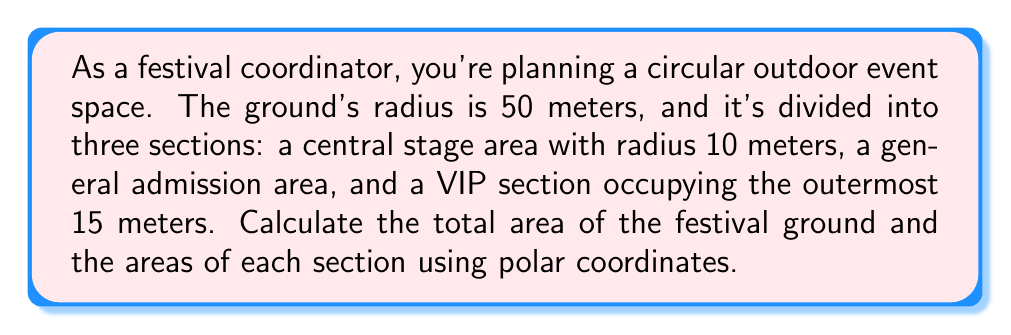Solve this math problem. To solve this problem, we'll use the formula for the area of a region in polar coordinates:

$$A = \frac{1}{2} \int_{0}^{2\pi} \int_{a}^{b} r^2 \, dr \, d\theta$$

Where $a$ and $b$ are the inner and outer radii of the region, respectively.

1. Total area of the festival ground:
   $$A_{total} = \frac{1}{2} \int_{0}^{2\pi} \int_{0}^{50} r^2 \, dr \, d\theta$$
   $$= \pi \int_{0}^{50} r^2 \, dr = \pi \left[ \frac{r^3}{3} \right]_{0}^{50}$$
   $$= \pi \cdot \frac{50^3}{3} = \frac{125000\pi}{3} \approx 130899.69 \, \text{m}^2$$

2. Central stage area:
   $$A_{stage} = \frac{1}{2} \int_{0}^{2\pi} \int_{0}^{10} r^2 \, dr \, d\theta$$
   $$= \pi \int_{0}^{10} r^2 \, dr = \pi \left[ \frac{r^3}{3} \right]_{0}^{10}$$
   $$= \pi \cdot \frac{10^3}{3} = \frac{1000\pi}{3} \approx 1047.20 \, \text{m}^2$$

3. VIP section area:
   $$A_{VIP} = \frac{1}{2} \int_{0}^{2\pi} \int_{35}^{50} r^2 \, dr \, d\theta$$
   $$= \pi \int_{35}^{50} r^2 \, dr = \pi \left[ \frac{r^3}{3} \right]_{35}^{50}$$
   $$= \pi \cdot \frac{50^3 - 35^3}{3} = \frac{91875\pi}{3} \approx 96130.44 \, \text{m}^2$$

4. General admission area:
   $$A_{general} = A_{total} - A_{stage} - A_{VIP}$$
   $$= \frac{125000\pi}{3} - \frac{1000\pi}{3} - \frac{91875\pi}{3}$$
   $$= \frac{32125\pi}{3} \approx 33722.05 \, \text{m}^2$$
Answer: Total festival ground area: $\frac{125000\pi}{3} \approx 130899.69 \, \text{m}^2$
Central stage area: $\frac{1000\pi}{3} \approx 1047.20 \, \text{m}^2$
VIP section area: $\frac{91875\pi}{3} \approx 96130.44 \, \text{m}^2$
General admission area: $\frac{32125\pi}{3} \approx 33722.05 \, \text{m}^2$ 